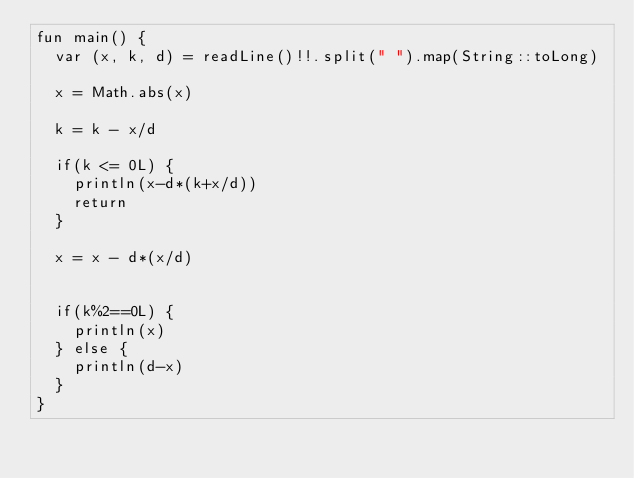Convert code to text. <code><loc_0><loc_0><loc_500><loc_500><_Kotlin_>fun main() {
  var (x, k, d) = readLine()!!.split(" ").map(String::toLong)
	
  x = Math.abs(x)
  
  k = k - x/d
  
  if(k <= 0L) {
    println(x-d*(k+x/d))
    return
  }
  
  x = x - d*(x/d)
  
  
  if(k%2==0L) {
    println(x)
  } else {
    println(d-x)
  }
}</code> 